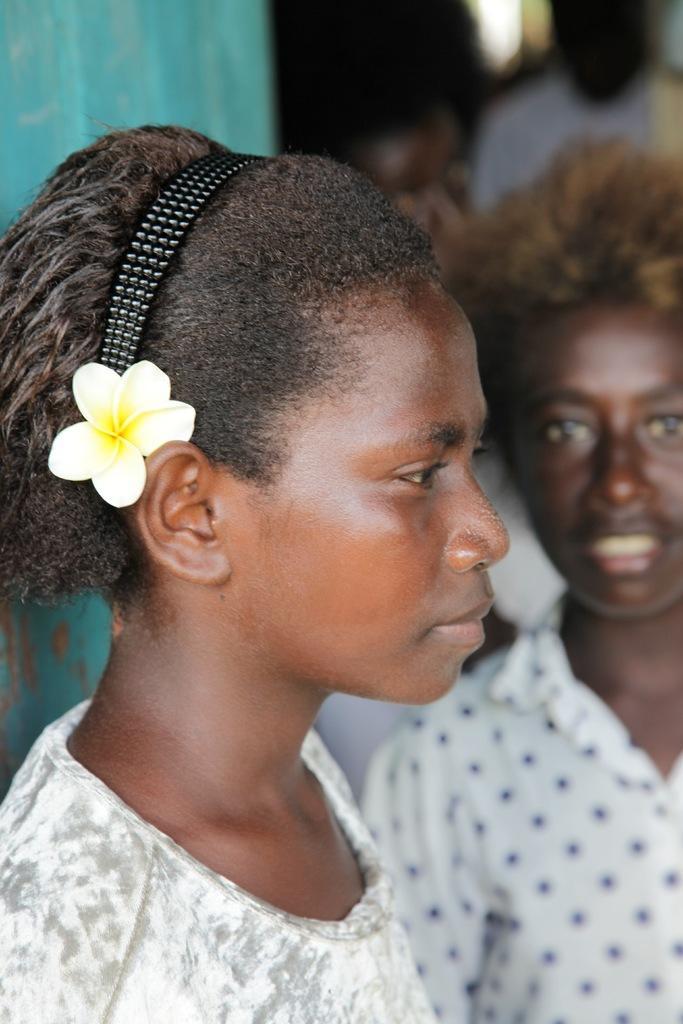Can you describe this image briefly? In this image there are persons, there is a person truncated towards the left of the image, there are persons truncated towards the right of the image, there is a person truncated towards the top of the image, there is an object truncated towards the left of the image. 